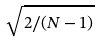<formula> <loc_0><loc_0><loc_500><loc_500>\sqrt { 2 / ( N - 1 ) }</formula> 